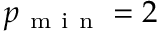<formula> <loc_0><loc_0><loc_500><loc_500>p _ { m i n } = 2</formula> 